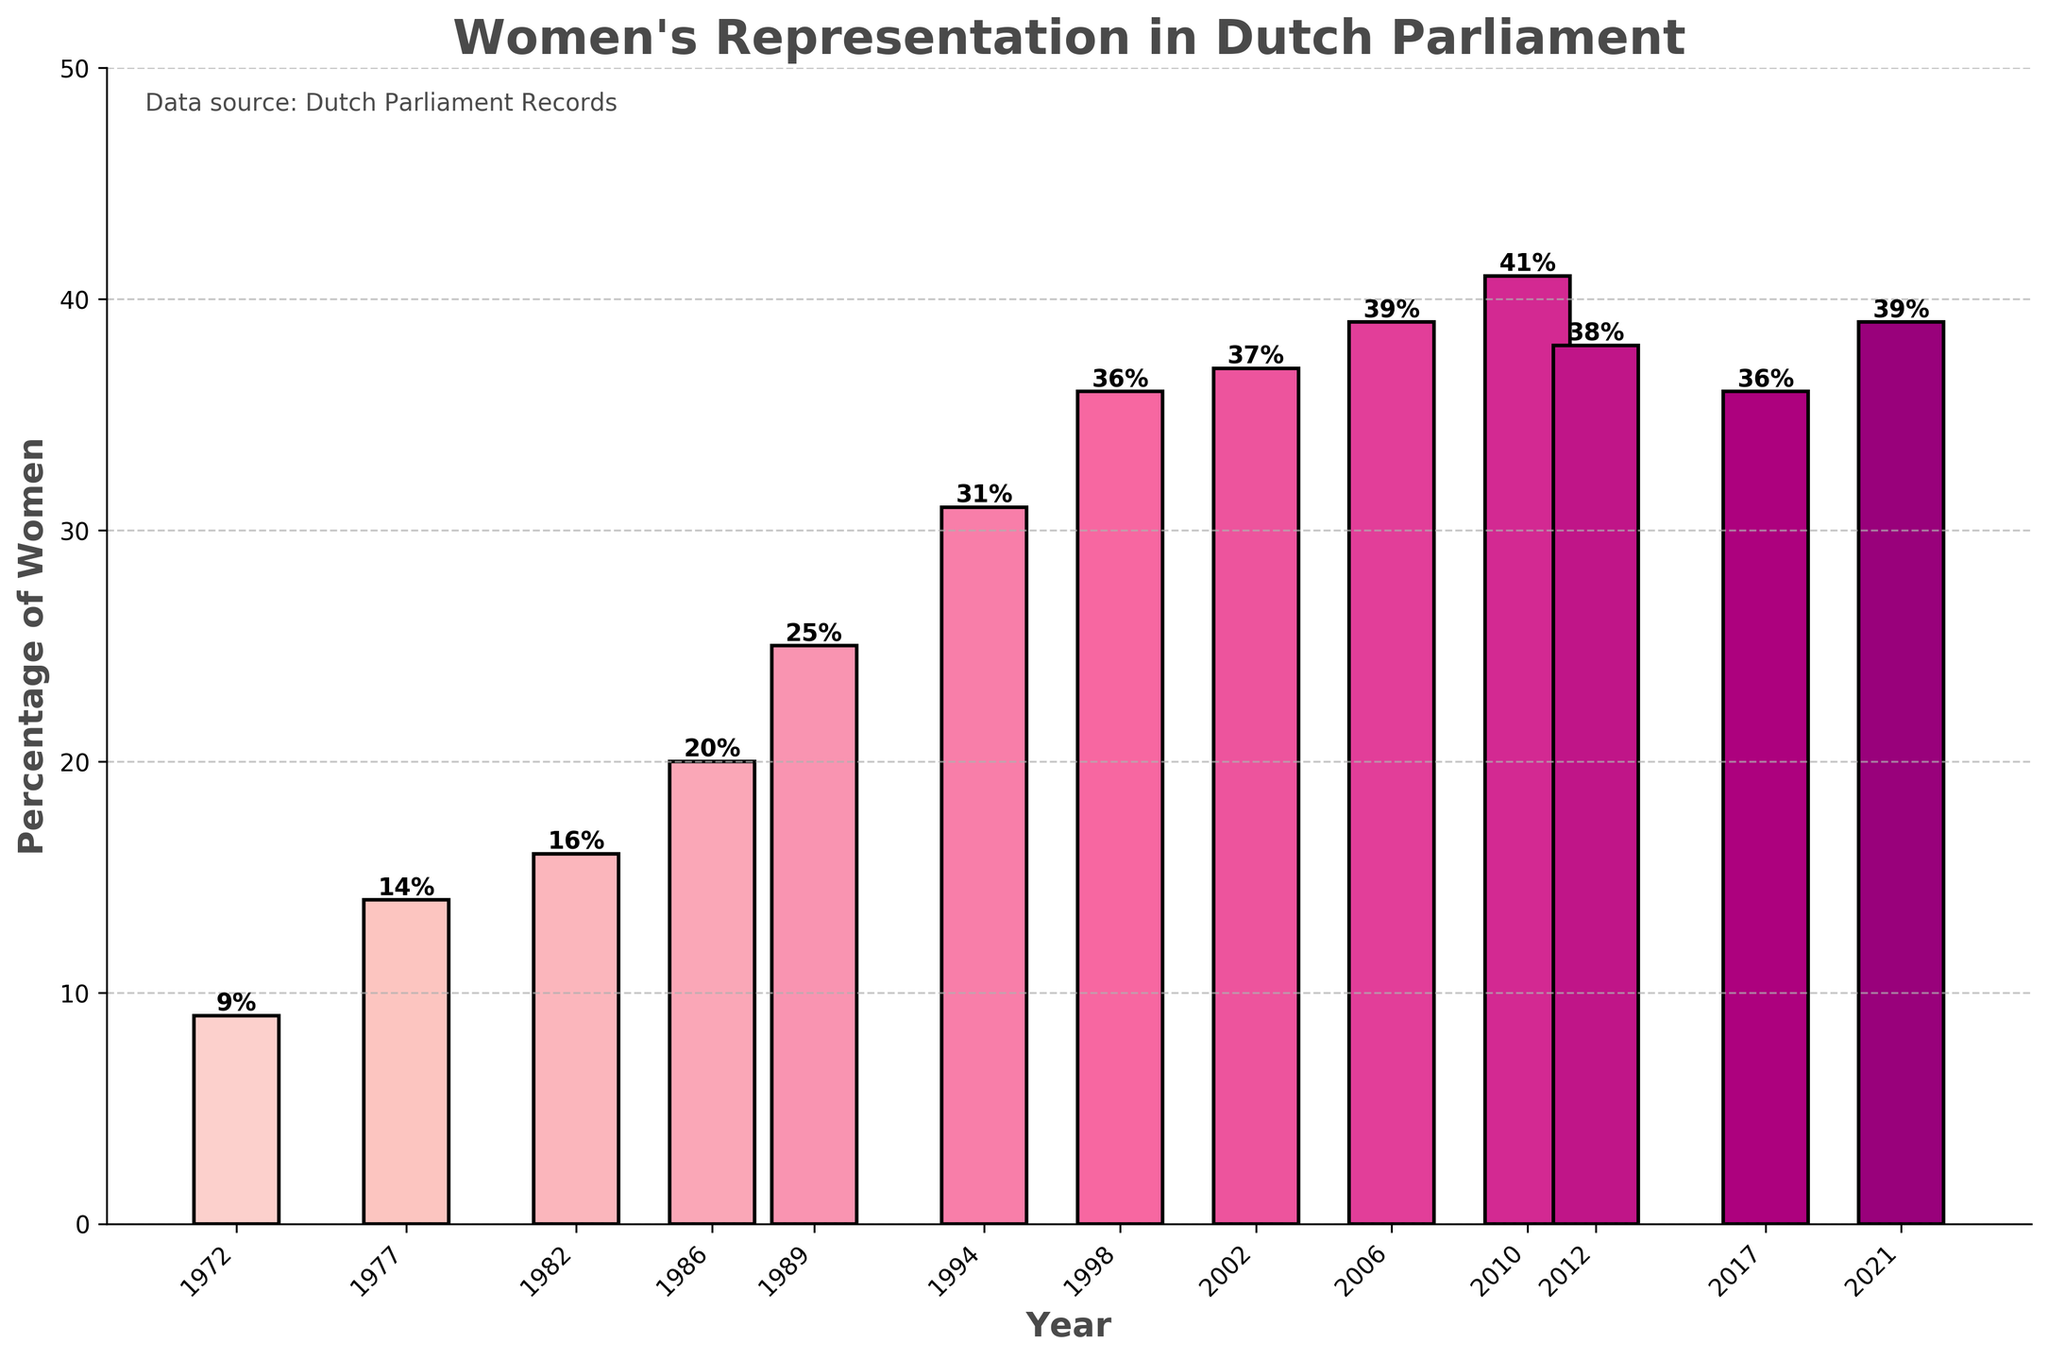What year had the lowest percentage of women in Dutch Parliament? From the bar chart, the bar for the year 1972 is the shortest, with a corresponding value of 9%. Thus, the year with the lowest percentage of women is 1972.
Answer: 1972 By how much did the percentage of women in Dutch Parliament increase from 1972 to 1982? The bar for 1972 indicates 9% and the bar for 1982 indicates 16%. The difference is calculated as 16% - 9%.
Answer: 7% Which year had the highest percentage of women in the Dutch Parliament, and what was the percentage? The tallest bar represents the highest percentage, which is for the year 2010, showing a value of 41%.
Answer: 2010, 41% What is the average percentage of women in Dutch Parliament from 2002 to 2021? The percentage values from 2002 to 2021 are 37, 39, 41, 38, 36, and 39. Summing these values gives 230. Dividing by the number of years (6) gives the average: 230/6 ≈ 38.33%.
Answer: 38.33% Between which consecutive years did the percentage of women in Dutch Parliament increase the most? By examining the heights of the bars, we find the differences between consecutive years. The largest increase is between 1989 (25%) and 1994 (31%), which is 6%.
Answer: 1989 to 1994 What is the trend of women's representation from 1972 to 2010? Observing the heights of the bars over this period shows a generally increasing trend from 9% in 1972 to 41% in 2010.
Answer: Increasing Compare the percentage change between 2006 and 2012. The percentage in 2006 is 39% and in 2012 it is 38%. The percentage change is (38-39)/39 * 100% = -2.56%.
Answer: -2.56% What is the total increase in the percentage of women from 1972 to 2021? The percentage was 9% in 1972 and 39% in 2021. The total increase is calculated as 39% - 9%.
Answer: 30% How many times did women's representation exceed 35% in the given years? By counting the bars above the 35% line, we have years 1998, 2002, 2006, 2010, 2012, and 2021, making 6 occurrences.
Answer: 6 times What is the median percentage of women in the given years? To find the median, the percentages are ordered: 9, 14, 16, 20, 25, 31, 36, 36, 37, 38, 39, 39, 41. The median value (7th in the list) is 36%.
Answer: 36% 